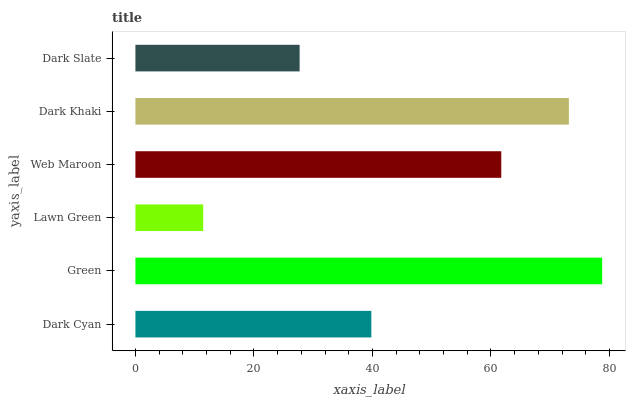Is Lawn Green the minimum?
Answer yes or no. Yes. Is Green the maximum?
Answer yes or no. Yes. Is Green the minimum?
Answer yes or no. No. Is Lawn Green the maximum?
Answer yes or no. No. Is Green greater than Lawn Green?
Answer yes or no. Yes. Is Lawn Green less than Green?
Answer yes or no. Yes. Is Lawn Green greater than Green?
Answer yes or no. No. Is Green less than Lawn Green?
Answer yes or no. No. Is Web Maroon the high median?
Answer yes or no. Yes. Is Dark Cyan the low median?
Answer yes or no. Yes. Is Green the high median?
Answer yes or no. No. Is Web Maroon the low median?
Answer yes or no. No. 